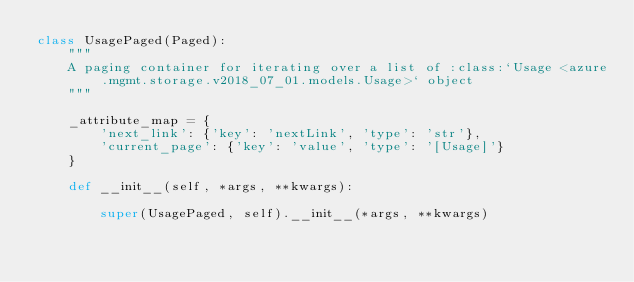<code> <loc_0><loc_0><loc_500><loc_500><_Python_>class UsagePaged(Paged):
    """
    A paging container for iterating over a list of :class:`Usage <azure.mgmt.storage.v2018_07_01.models.Usage>` object
    """

    _attribute_map = {
        'next_link': {'key': 'nextLink', 'type': 'str'},
        'current_page': {'key': 'value', 'type': '[Usage]'}
    }

    def __init__(self, *args, **kwargs):

        super(UsagePaged, self).__init__(*args, **kwargs)
</code> 